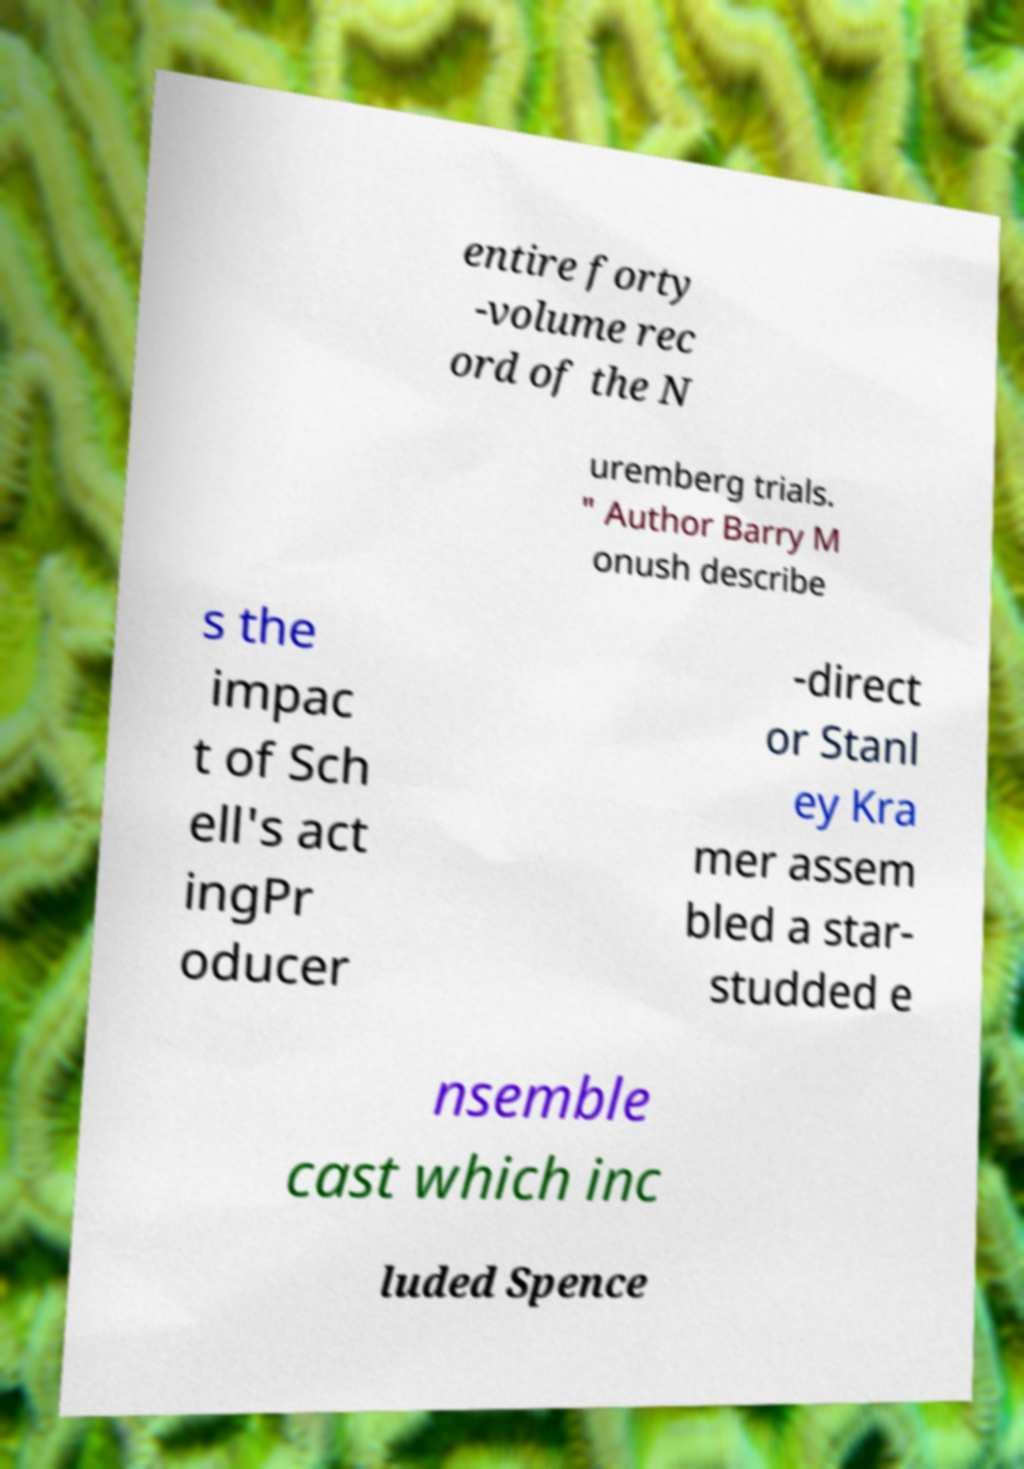Please read and relay the text visible in this image. What does it say? entire forty -volume rec ord of the N uremberg trials. " Author Barry M onush describe s the impac t of Sch ell's act ingPr oducer -direct or Stanl ey Kra mer assem bled a star- studded e nsemble cast which inc luded Spence 